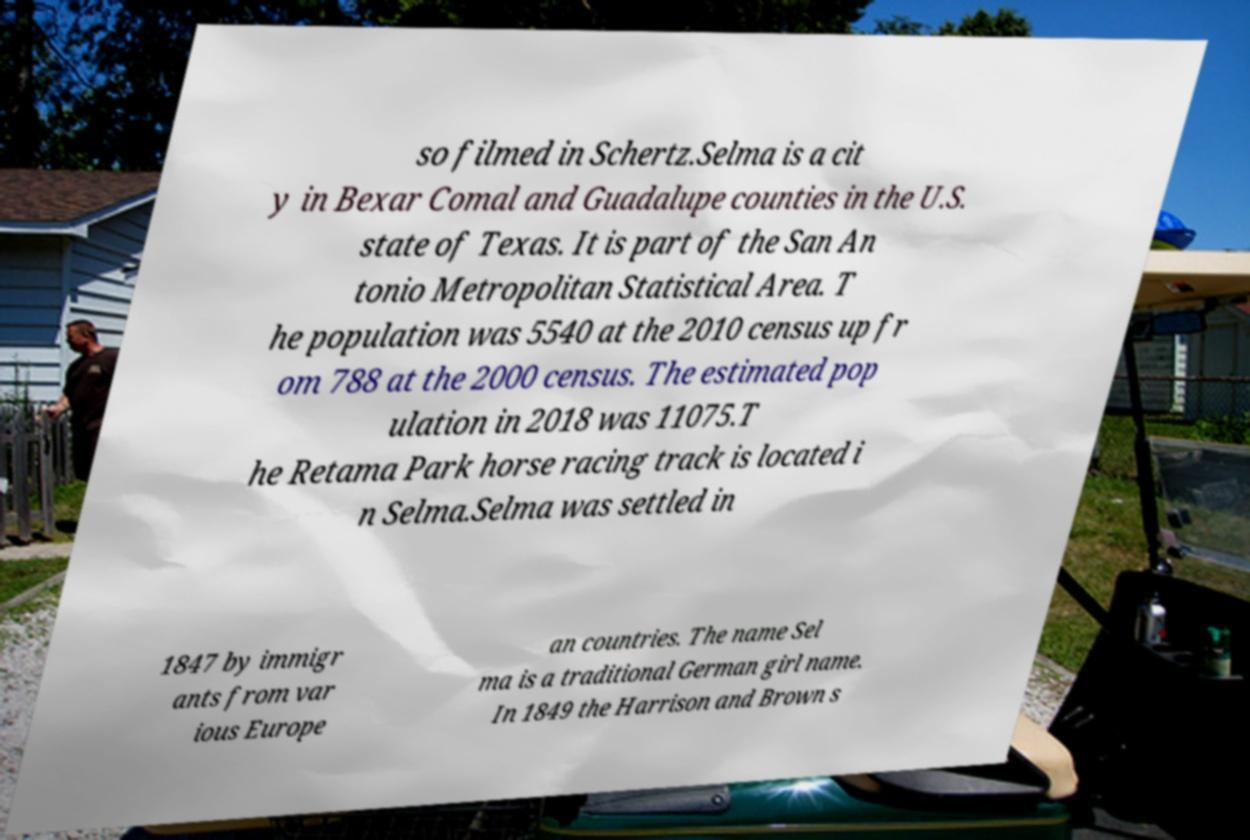Can you read and provide the text displayed in the image?This photo seems to have some interesting text. Can you extract and type it out for me? so filmed in Schertz.Selma is a cit y in Bexar Comal and Guadalupe counties in the U.S. state of Texas. It is part of the San An tonio Metropolitan Statistical Area. T he population was 5540 at the 2010 census up fr om 788 at the 2000 census. The estimated pop ulation in 2018 was 11075.T he Retama Park horse racing track is located i n Selma.Selma was settled in 1847 by immigr ants from var ious Europe an countries. The name Sel ma is a traditional German girl name. In 1849 the Harrison and Brown s 